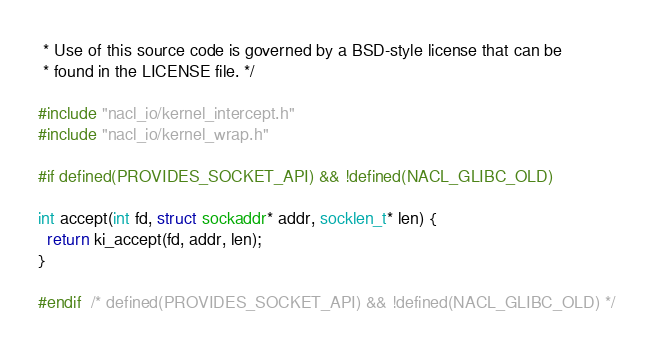Convert code to text. <code><loc_0><loc_0><loc_500><loc_500><_C_> * Use of this source code is governed by a BSD-style license that can be
 * found in the LICENSE file. */

#include "nacl_io/kernel_intercept.h"
#include "nacl_io/kernel_wrap.h"

#if defined(PROVIDES_SOCKET_API) && !defined(NACL_GLIBC_OLD)

int accept(int fd, struct sockaddr* addr, socklen_t* len) {
  return ki_accept(fd, addr, len);
}

#endif  /* defined(PROVIDES_SOCKET_API) && !defined(NACL_GLIBC_OLD) */
</code> 